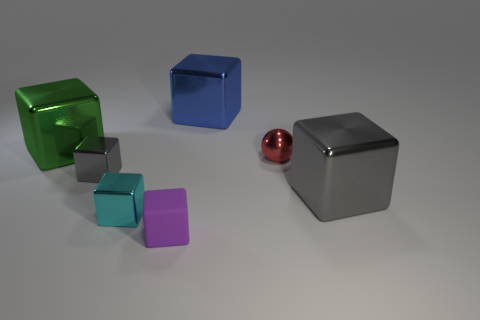Subtract all metal blocks. How many blocks are left? 1 Subtract all cyan cubes. How many cubes are left? 5 Subtract all purple blocks. Subtract all red spheres. How many blocks are left? 5 Add 1 blue objects. How many objects exist? 8 Subtract all blocks. How many objects are left? 1 Add 4 blue objects. How many blue objects exist? 5 Subtract 0 gray spheres. How many objects are left? 7 Subtract all tiny cyan metallic things. Subtract all purple cubes. How many objects are left? 5 Add 6 blue metallic blocks. How many blue metallic blocks are left? 7 